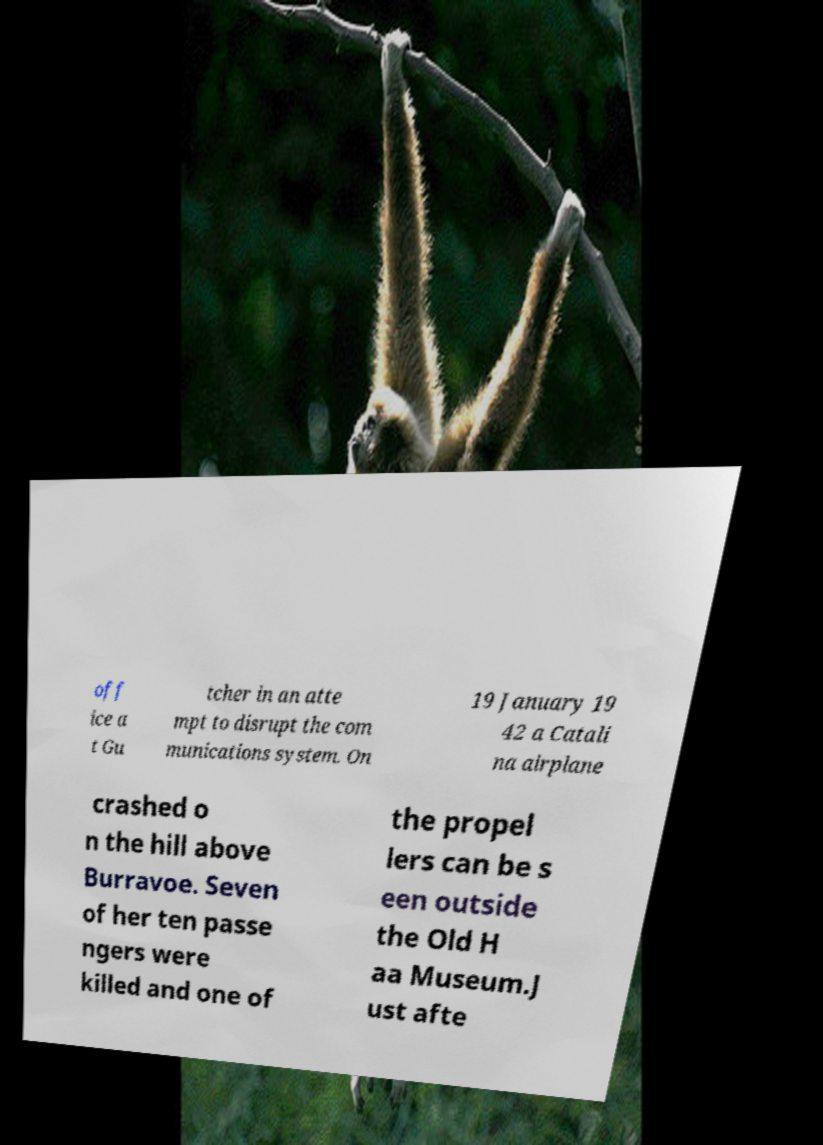I need the written content from this picture converted into text. Can you do that? off ice a t Gu tcher in an atte mpt to disrupt the com munications system. On 19 January 19 42 a Catali na airplane crashed o n the hill above Burravoe. Seven of her ten passe ngers were killed and one of the propel lers can be s een outside the Old H aa Museum.J ust afte 